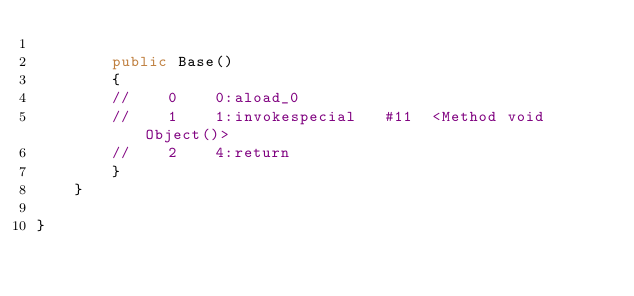<code> <loc_0><loc_0><loc_500><loc_500><_Java_>
		public Base()
		{
		//    0    0:aload_0         
		//    1    1:invokespecial   #11  <Method void Object()>
		//    2    4:return          
		}
	}

}
</code> 